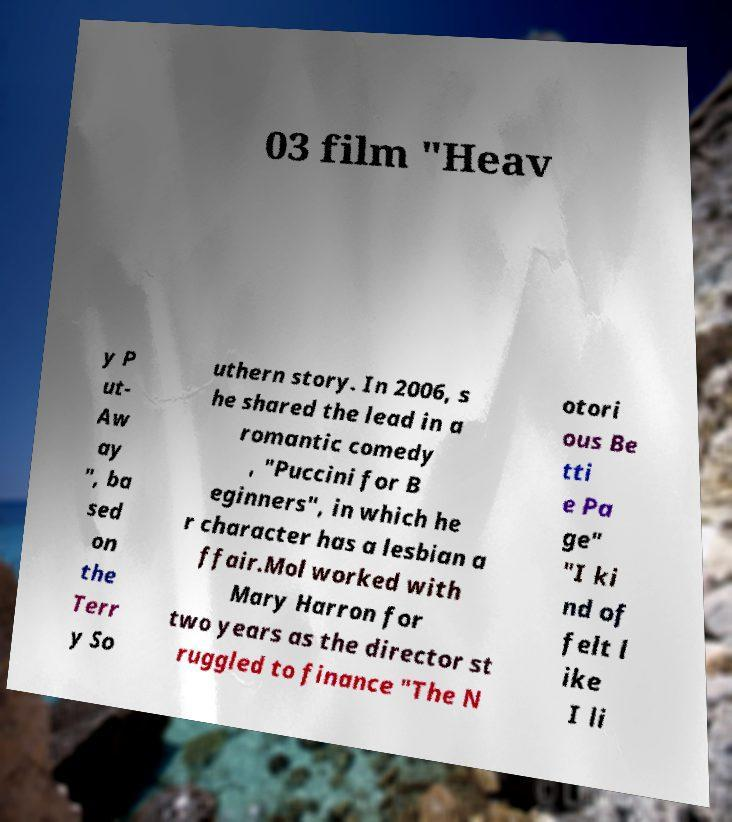Please read and relay the text visible in this image. What does it say? 03 film "Heav y P ut- Aw ay ", ba sed on the Terr y So uthern story. In 2006, s he shared the lead in a romantic comedy , "Puccini for B eginners", in which he r character has a lesbian a ffair.Mol worked with Mary Harron for two years as the director st ruggled to finance "The N otori ous Be tti e Pa ge" "I ki nd of felt l ike I li 